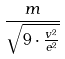<formula> <loc_0><loc_0><loc_500><loc_500>\frac { m } { \sqrt { 9 \cdot \frac { v ^ { 2 } } { e ^ { 2 } } } }</formula> 